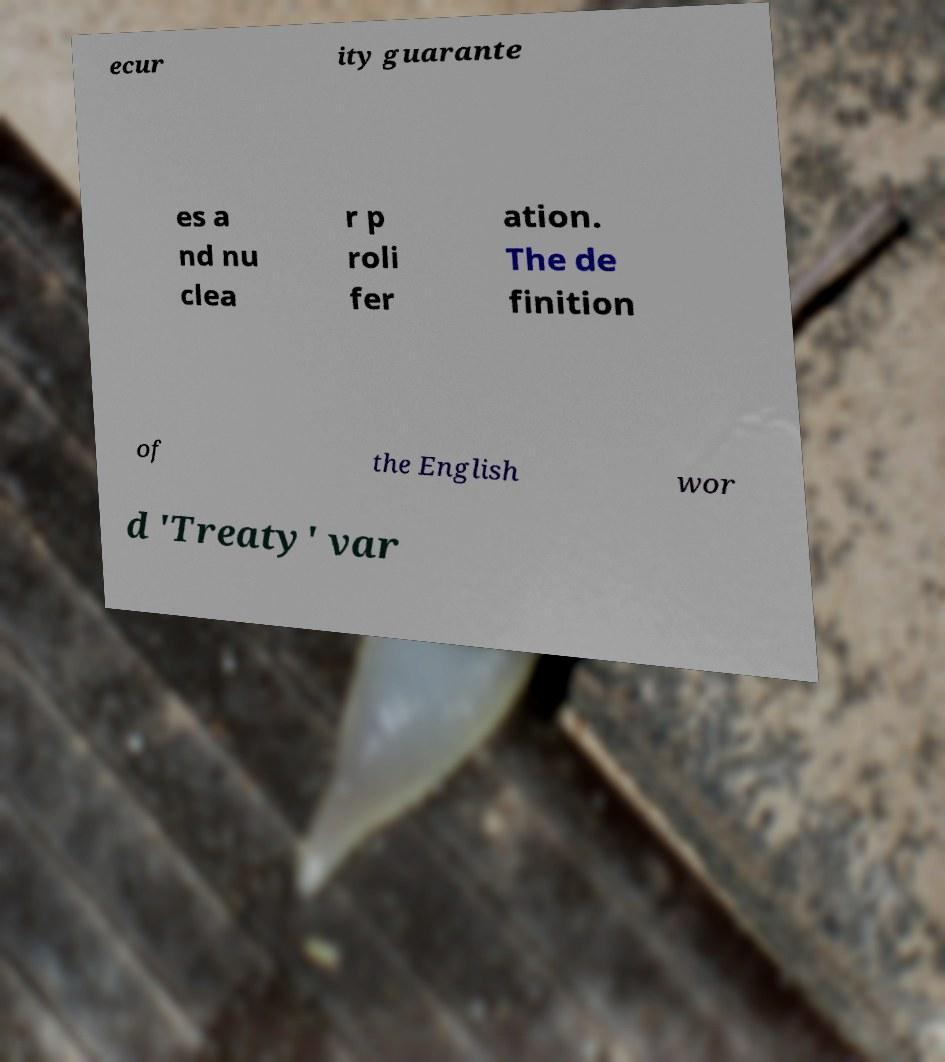I need the written content from this picture converted into text. Can you do that? ecur ity guarante es a nd nu clea r p roli fer ation. The de finition of the English wor d 'Treaty' var 